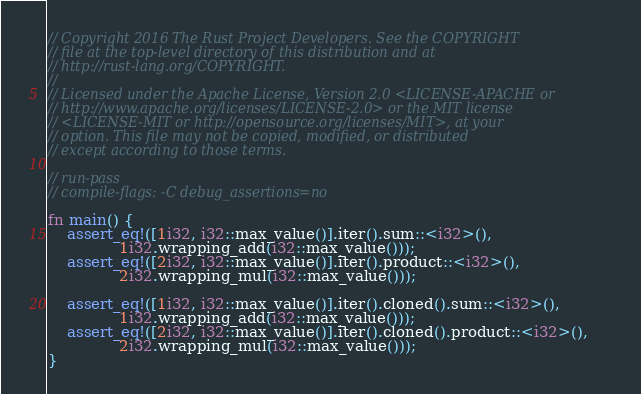Convert code to text. <code><loc_0><loc_0><loc_500><loc_500><_Rust_>// Copyright 2016 The Rust Project Developers. See the COPYRIGHT
// file at the top-level directory of this distribution and at
// http://rust-lang.org/COPYRIGHT.
//
// Licensed under the Apache License, Version 2.0 <LICENSE-APACHE or
// http://www.apache.org/licenses/LICENSE-2.0> or the MIT license
// <LICENSE-MIT or http://opensource.org/licenses/MIT>, at your
// option. This file may not be copied, modified, or distributed
// except according to those terms.

// run-pass
// compile-flags: -C debug_assertions=no

fn main() {
    assert_eq!([1i32, i32::max_value()].iter().sum::<i32>(),
               1i32.wrapping_add(i32::max_value()));
    assert_eq!([2i32, i32::max_value()].iter().product::<i32>(),
               2i32.wrapping_mul(i32::max_value()));

    assert_eq!([1i32, i32::max_value()].iter().cloned().sum::<i32>(),
               1i32.wrapping_add(i32::max_value()));
    assert_eq!([2i32, i32::max_value()].iter().cloned().product::<i32>(),
               2i32.wrapping_mul(i32::max_value()));
}
</code> 